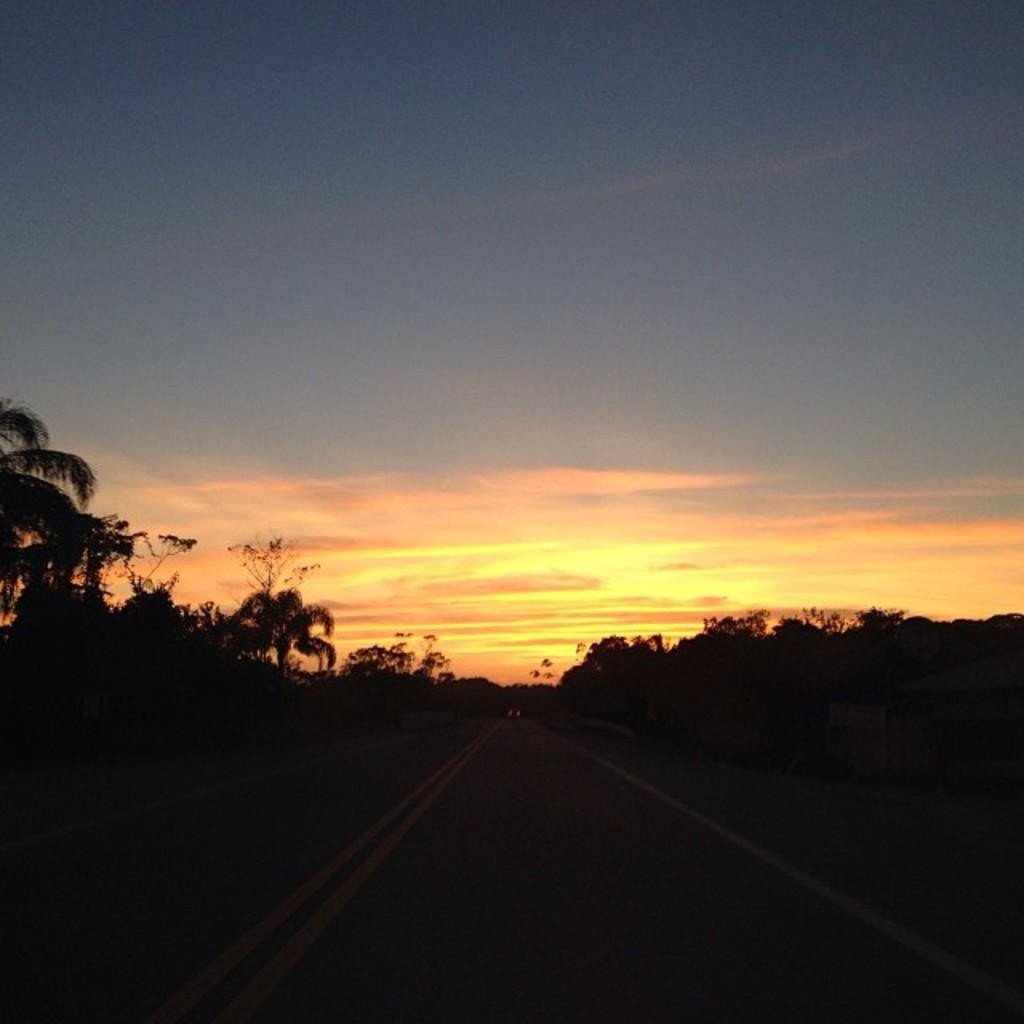What type of natural elements can be seen in the image? There are trees in the image. What man-made feature is present in the image? There is a road in the image. Can you describe any other objects in the image besides the trees and road? Yes, there are other objects in the image. What can be seen in the background of the image? The sky is visible in the background of the image. What type of iron is being used to create a thrilling experience in the image? There is no iron or thrilling experience present in the image; it features trees, a road, and other objects with the sky visible in the background. 